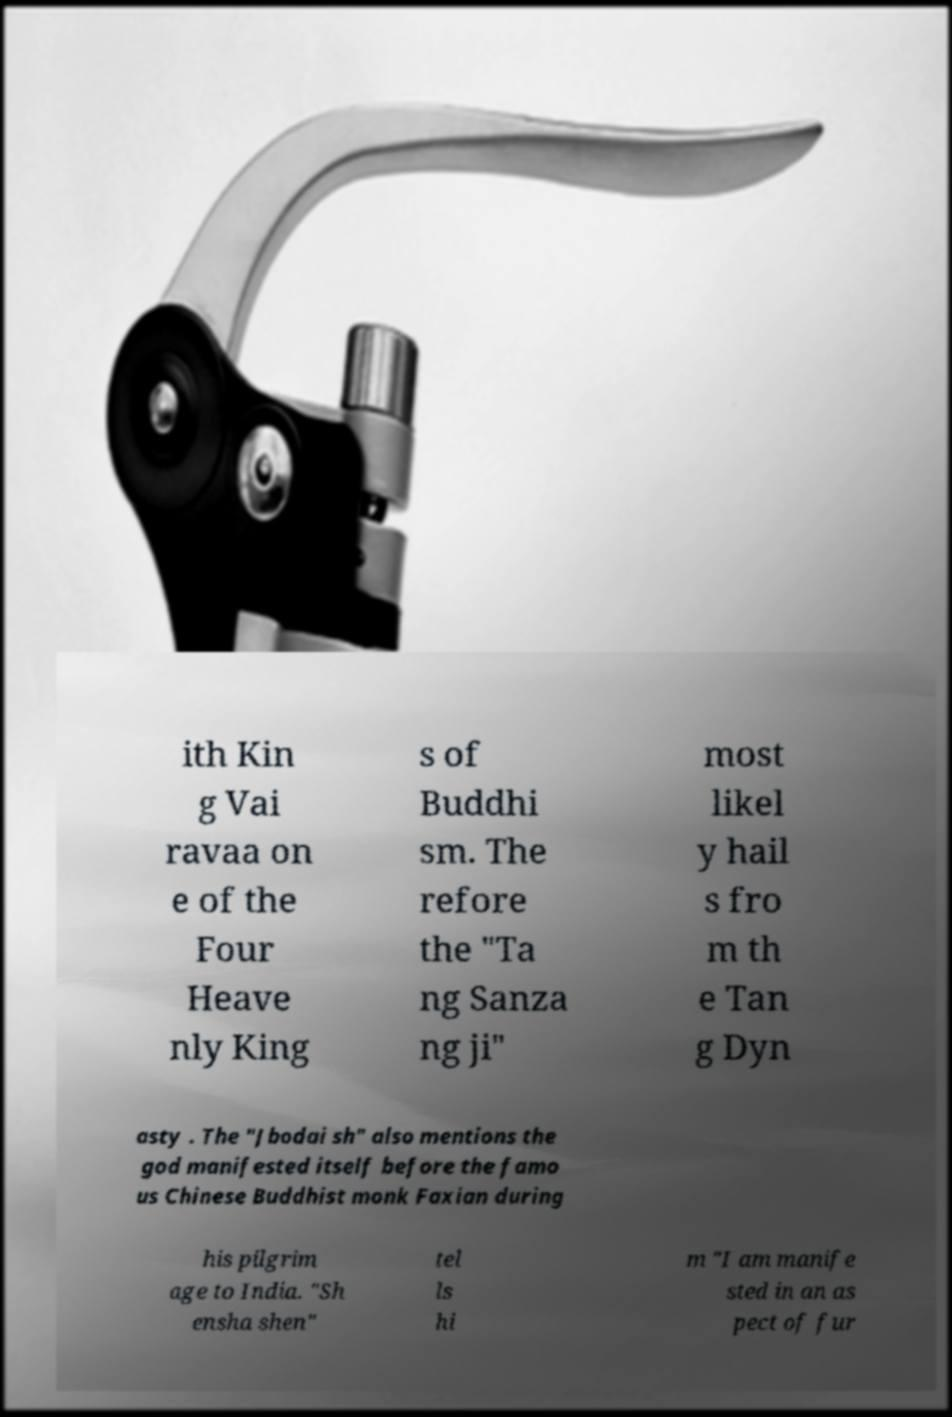I need the written content from this picture converted into text. Can you do that? ith Kin g Vai ravaa on e of the Four Heave nly King s of Buddhi sm. The refore the "Ta ng Sanza ng ji" most likel y hail s fro m th e Tan g Dyn asty . The "Jbodai sh" also mentions the god manifested itself before the famo us Chinese Buddhist monk Faxian during his pilgrim age to India. "Sh ensha shen" tel ls hi m "I am manife sted in an as pect of fur 